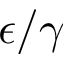Convert formula to latex. <formula><loc_0><loc_0><loc_500><loc_500>\epsilon / \gamma</formula> 